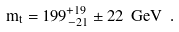<formula> <loc_0><loc_0><loc_500><loc_500>m _ { t } = 1 9 9 _ { - 2 1 } ^ { + 1 9 } \pm 2 2 \ G e V \ .</formula> 